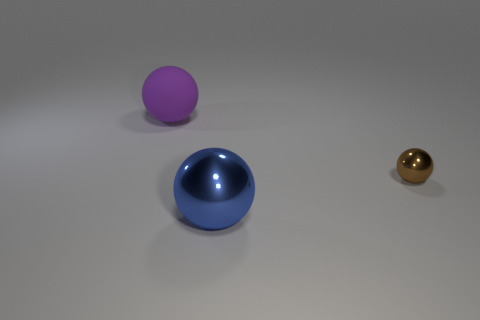Subtract all metal balls. How many balls are left? 1 Add 3 brown metal balls. How many objects exist? 6 Add 2 big purple things. How many big purple things exist? 3 Subtract 0 brown cylinders. How many objects are left? 3 Subtract all large gray cubes. Subtract all big objects. How many objects are left? 1 Add 1 small brown things. How many small brown things are left? 2 